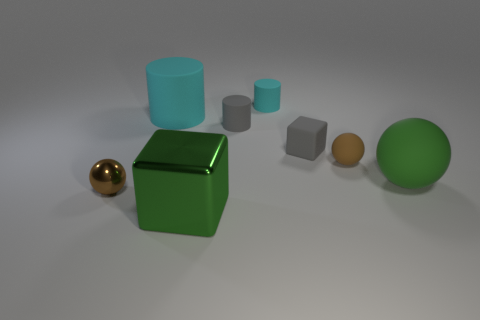Is there a large thing that has the same shape as the small brown rubber object?
Offer a terse response. Yes. There is a shiny thing right of the shiny ball; is its shape the same as the gray thing that is in front of the gray matte cylinder?
Your answer should be very brief. Yes. There is another brown object that is the same size as the brown rubber object; what material is it?
Make the answer very short. Metal. How many other things are there of the same material as the big block?
Give a very brief answer. 1. The cyan rubber object that is to the right of the block that is in front of the tiny metal thing is what shape?
Your response must be concise. Cylinder. How many things are brown objects or small balls on the right side of the big green cube?
Offer a very short reply. 2. How many other things are there of the same color as the large cylinder?
Keep it short and to the point. 1. What number of cyan things are either large matte objects or spheres?
Offer a very short reply. 1. There is a matte sphere that is on the right side of the small rubber object in front of the small gray cube; is there a large green object that is in front of it?
Provide a short and direct response. Yes. Does the big cube have the same color as the large matte sphere?
Your response must be concise. Yes. 